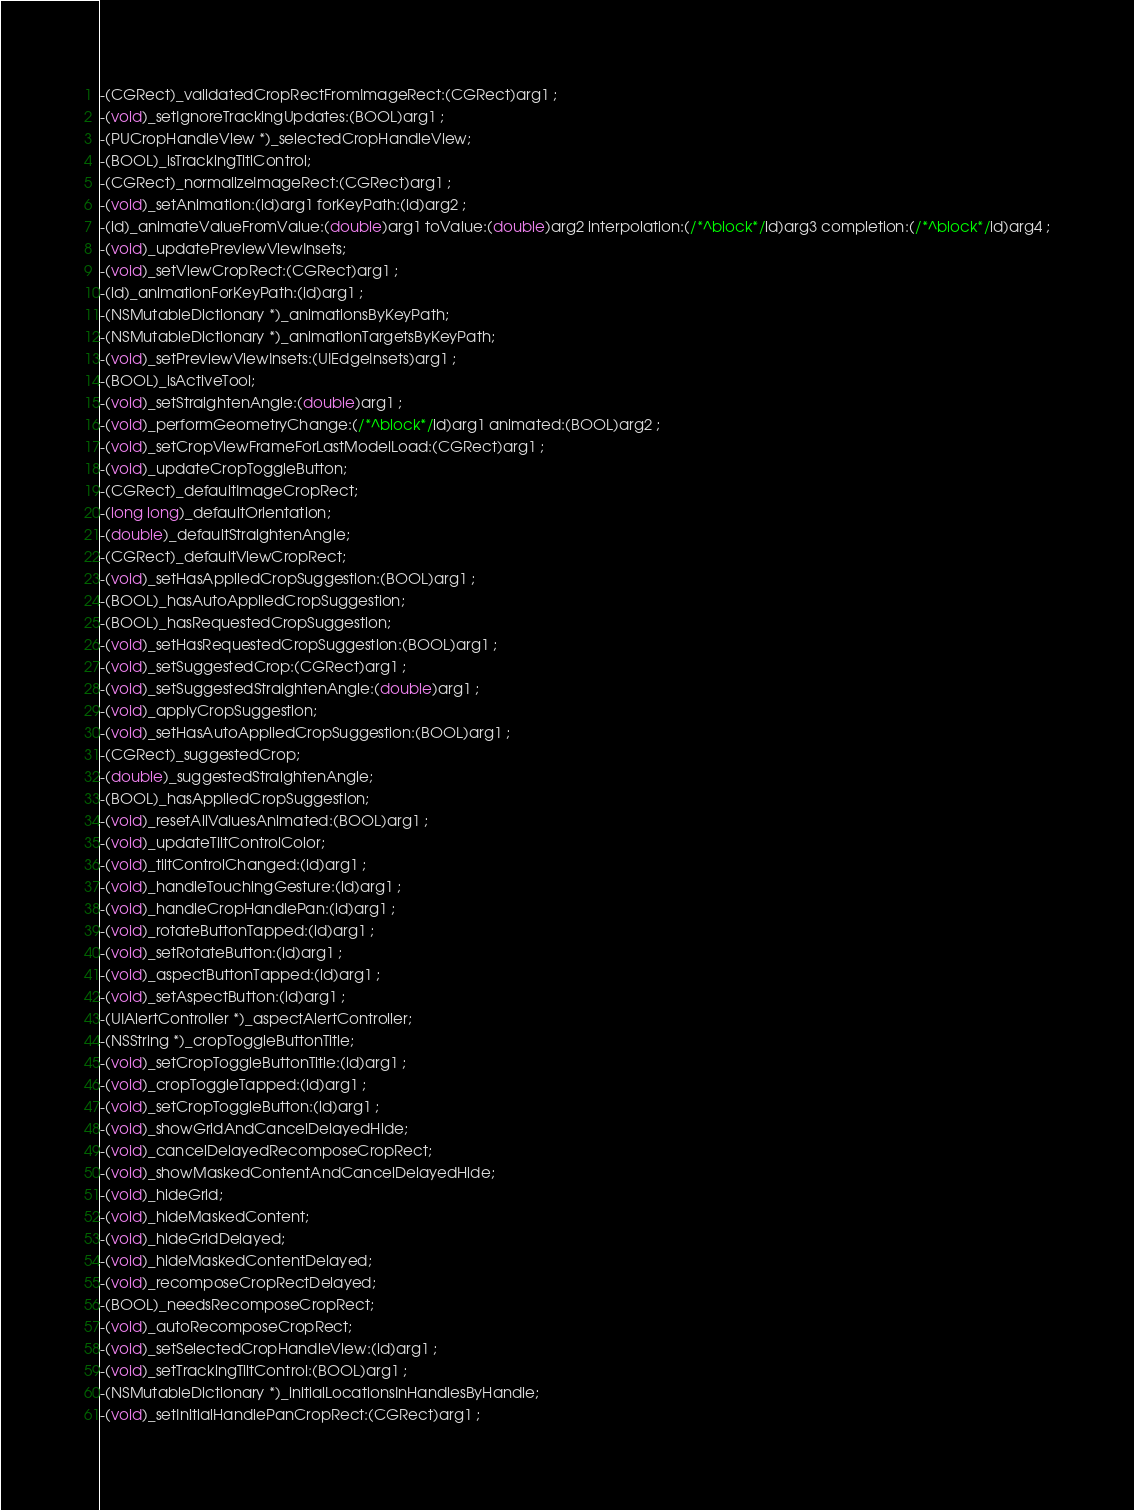<code> <loc_0><loc_0><loc_500><loc_500><_C_>-(CGRect)_validatedCropRectFromImageRect:(CGRect)arg1 ;
-(void)_setIgnoreTrackingUpdates:(BOOL)arg1 ;
-(PUCropHandleView *)_selectedCropHandleView;
-(BOOL)_isTrackingTitlControl;
-(CGRect)_normalizeImageRect:(CGRect)arg1 ;
-(void)_setAnimation:(id)arg1 forKeyPath:(id)arg2 ;
-(id)_animateValueFromValue:(double)arg1 toValue:(double)arg2 interpolation:(/*^block*/id)arg3 completion:(/*^block*/id)arg4 ;
-(void)_updatePreviewViewInsets;
-(void)_setViewCropRect:(CGRect)arg1 ;
-(id)_animationForKeyPath:(id)arg1 ;
-(NSMutableDictionary *)_animationsByKeyPath;
-(NSMutableDictionary *)_animationTargetsByKeyPath;
-(void)_setPreviewViewInsets:(UIEdgeInsets)arg1 ;
-(BOOL)_isActiveTool;
-(void)_setStraightenAngle:(double)arg1 ;
-(void)_performGeometryChange:(/*^block*/id)arg1 animated:(BOOL)arg2 ;
-(void)_setCropViewFrameForLastModelLoad:(CGRect)arg1 ;
-(void)_updateCropToggleButton;
-(CGRect)_defaultImageCropRect;
-(long long)_defaultOrientation;
-(double)_defaultStraightenAngle;
-(CGRect)_defaultViewCropRect;
-(void)_setHasAppliedCropSuggestion:(BOOL)arg1 ;
-(BOOL)_hasAutoAppliedCropSuggestion;
-(BOOL)_hasRequestedCropSuggestion;
-(void)_setHasRequestedCropSuggestion:(BOOL)arg1 ;
-(void)_setSuggestedCrop:(CGRect)arg1 ;
-(void)_setSuggestedStraightenAngle:(double)arg1 ;
-(void)_applyCropSuggestion;
-(void)_setHasAutoAppliedCropSuggestion:(BOOL)arg1 ;
-(CGRect)_suggestedCrop;
-(double)_suggestedStraightenAngle;
-(BOOL)_hasAppliedCropSuggestion;
-(void)_resetAllValuesAnimated:(BOOL)arg1 ;
-(void)_updateTiltControlColor;
-(void)_tiltControlChanged:(id)arg1 ;
-(void)_handleTouchingGesture:(id)arg1 ;
-(void)_handleCropHandlePan:(id)arg1 ;
-(void)_rotateButtonTapped:(id)arg1 ;
-(void)_setRotateButton:(id)arg1 ;
-(void)_aspectButtonTapped:(id)arg1 ;
-(void)_setAspectButton:(id)arg1 ;
-(UIAlertController *)_aspectAlertController;
-(NSString *)_cropToggleButtonTitle;
-(void)_setCropToggleButtonTitle:(id)arg1 ;
-(void)_cropToggleTapped:(id)arg1 ;
-(void)_setCropToggleButton:(id)arg1 ;
-(void)_showGridAndCancelDelayedHide;
-(void)_cancelDelayedRecomposeCropRect;
-(void)_showMaskedContentAndCancelDelayedHide;
-(void)_hideGrid;
-(void)_hideMaskedContent;
-(void)_hideGridDelayed;
-(void)_hideMaskedContentDelayed;
-(void)_recomposeCropRectDelayed;
-(BOOL)_needsRecomposeCropRect;
-(void)_autoRecomposeCropRect;
-(void)_setSelectedCropHandleView:(id)arg1 ;
-(void)_setTrackingTiltControl:(BOOL)arg1 ;
-(NSMutableDictionary *)_initialLocationsInHandlesByHandle;
-(void)_setInitialHandlePanCropRect:(CGRect)arg1 ;</code> 